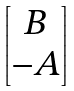<formula> <loc_0><loc_0><loc_500><loc_500>\begin{bmatrix} B \\ - A \end{bmatrix}</formula> 